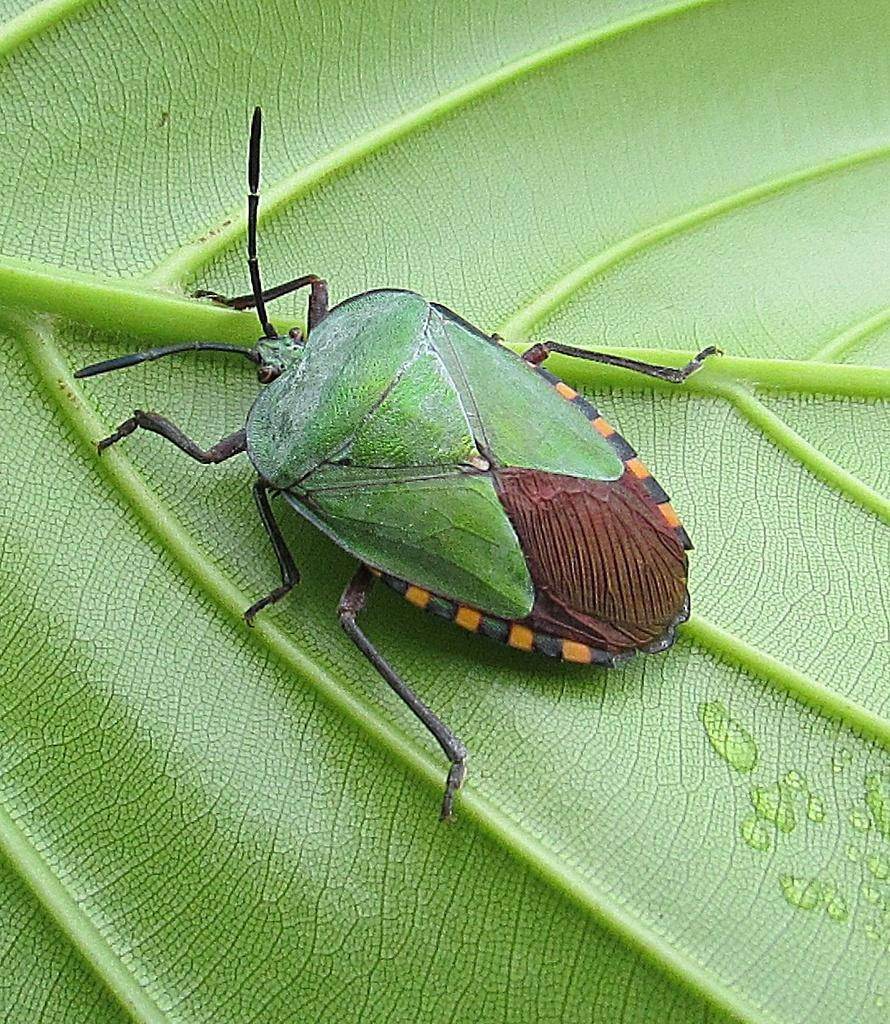What is present in the picture? There is a bug in the picture. Where is the bug located? The bug is on a leaf. What colors can be seen on the bug? The bug is green in color, with some parts being brown. What is the bug's tendency to engage in friction with the leaf? The bug's tendency to engage in friction with the leaf cannot be determined from the image. 